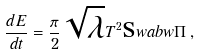<formula> <loc_0><loc_0><loc_500><loc_500>\frac { d E } { d t } = \frac { \pi } { 2 } \sqrt { \lambda } T ^ { 2 } \text  swab{w} \Pi \, ,</formula> 